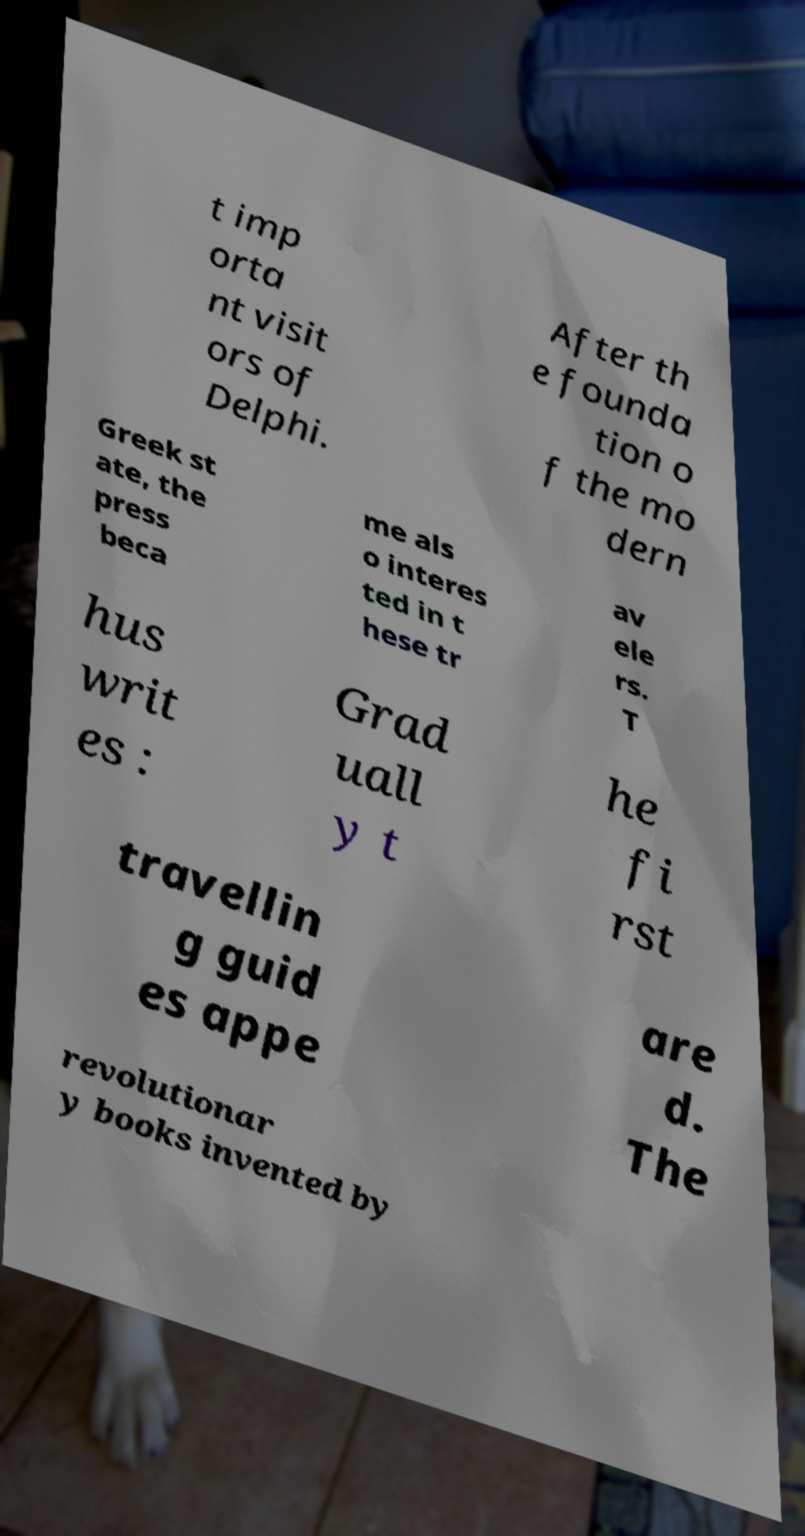For documentation purposes, I need the text within this image transcribed. Could you provide that? t imp orta nt visit ors of Delphi. After th e founda tion o f the mo dern Greek st ate, the press beca me als o interes ted in t hese tr av ele rs. T hus writ es : Grad uall y t he fi rst travellin g guid es appe are d. The revolutionar y books invented by 